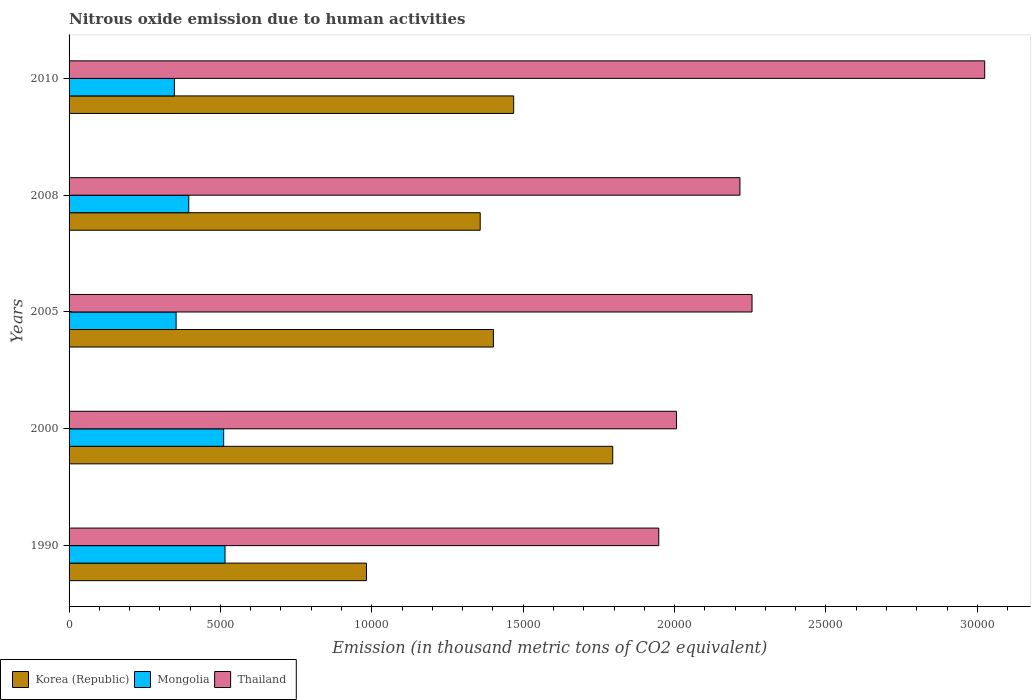How many different coloured bars are there?
Keep it short and to the point. 3. Are the number of bars per tick equal to the number of legend labels?
Offer a very short reply. Yes. How many bars are there on the 5th tick from the top?
Ensure brevity in your answer.  3. What is the label of the 3rd group of bars from the top?
Offer a very short reply. 2005. In how many cases, is the number of bars for a given year not equal to the number of legend labels?
Your answer should be compact. 0. What is the amount of nitrous oxide emitted in Thailand in 2000?
Your answer should be very brief. 2.01e+04. Across all years, what is the maximum amount of nitrous oxide emitted in Thailand?
Give a very brief answer. 3.02e+04. Across all years, what is the minimum amount of nitrous oxide emitted in Mongolia?
Your response must be concise. 3478.2. In which year was the amount of nitrous oxide emitted in Korea (Republic) maximum?
Give a very brief answer. 2000. What is the total amount of nitrous oxide emitted in Mongolia in the graph?
Keep it short and to the point. 2.12e+04. What is the difference between the amount of nitrous oxide emitted in Korea (Republic) in 2000 and that in 2010?
Offer a very short reply. 3272.5. What is the difference between the amount of nitrous oxide emitted in Korea (Republic) in 2010 and the amount of nitrous oxide emitted in Thailand in 2008?
Provide a short and direct response. -7473.8. What is the average amount of nitrous oxide emitted in Korea (Republic) per year?
Provide a succinct answer. 1.40e+04. In the year 2010, what is the difference between the amount of nitrous oxide emitted in Thailand and amount of nitrous oxide emitted in Mongolia?
Your answer should be compact. 2.68e+04. In how many years, is the amount of nitrous oxide emitted in Thailand greater than 16000 thousand metric tons?
Your response must be concise. 5. What is the ratio of the amount of nitrous oxide emitted in Mongolia in 1990 to that in 2000?
Make the answer very short. 1.01. What is the difference between the highest and the second highest amount of nitrous oxide emitted in Korea (Republic)?
Offer a very short reply. 3272.5. What is the difference between the highest and the lowest amount of nitrous oxide emitted in Thailand?
Your answer should be very brief. 1.08e+04. In how many years, is the amount of nitrous oxide emitted in Thailand greater than the average amount of nitrous oxide emitted in Thailand taken over all years?
Offer a very short reply. 1. What does the 2nd bar from the bottom in 2008 represents?
Provide a succinct answer. Mongolia. How many bars are there?
Offer a terse response. 15. Are all the bars in the graph horizontal?
Your response must be concise. Yes. How many years are there in the graph?
Make the answer very short. 5. What is the difference between two consecutive major ticks on the X-axis?
Your answer should be compact. 5000. Are the values on the major ticks of X-axis written in scientific E-notation?
Make the answer very short. No. Does the graph contain any zero values?
Offer a terse response. No. Does the graph contain grids?
Ensure brevity in your answer.  No. How many legend labels are there?
Offer a very short reply. 3. How are the legend labels stacked?
Keep it short and to the point. Horizontal. What is the title of the graph?
Your answer should be compact. Nitrous oxide emission due to human activities. Does "Uganda" appear as one of the legend labels in the graph?
Ensure brevity in your answer.  No. What is the label or title of the X-axis?
Make the answer very short. Emission (in thousand metric tons of CO2 equivalent). What is the Emission (in thousand metric tons of CO2 equivalent) of Korea (Republic) in 1990?
Ensure brevity in your answer.  9823.4. What is the Emission (in thousand metric tons of CO2 equivalent) of Mongolia in 1990?
Ensure brevity in your answer.  5151. What is the Emission (in thousand metric tons of CO2 equivalent) of Thailand in 1990?
Ensure brevity in your answer.  1.95e+04. What is the Emission (in thousand metric tons of CO2 equivalent) in Korea (Republic) in 2000?
Keep it short and to the point. 1.80e+04. What is the Emission (in thousand metric tons of CO2 equivalent) of Mongolia in 2000?
Your answer should be very brief. 5106.8. What is the Emission (in thousand metric tons of CO2 equivalent) of Thailand in 2000?
Keep it short and to the point. 2.01e+04. What is the Emission (in thousand metric tons of CO2 equivalent) of Korea (Republic) in 2005?
Offer a terse response. 1.40e+04. What is the Emission (in thousand metric tons of CO2 equivalent) of Mongolia in 2005?
Offer a terse response. 3535.4. What is the Emission (in thousand metric tons of CO2 equivalent) in Thailand in 2005?
Provide a short and direct response. 2.26e+04. What is the Emission (in thousand metric tons of CO2 equivalent) in Korea (Republic) in 2008?
Your answer should be compact. 1.36e+04. What is the Emission (in thousand metric tons of CO2 equivalent) of Mongolia in 2008?
Give a very brief answer. 3953.8. What is the Emission (in thousand metric tons of CO2 equivalent) in Thailand in 2008?
Ensure brevity in your answer.  2.22e+04. What is the Emission (in thousand metric tons of CO2 equivalent) of Korea (Republic) in 2010?
Keep it short and to the point. 1.47e+04. What is the Emission (in thousand metric tons of CO2 equivalent) of Mongolia in 2010?
Your answer should be compact. 3478.2. What is the Emission (in thousand metric tons of CO2 equivalent) of Thailand in 2010?
Offer a terse response. 3.02e+04. Across all years, what is the maximum Emission (in thousand metric tons of CO2 equivalent) in Korea (Republic)?
Your answer should be very brief. 1.80e+04. Across all years, what is the maximum Emission (in thousand metric tons of CO2 equivalent) in Mongolia?
Give a very brief answer. 5151. Across all years, what is the maximum Emission (in thousand metric tons of CO2 equivalent) in Thailand?
Your response must be concise. 3.02e+04. Across all years, what is the minimum Emission (in thousand metric tons of CO2 equivalent) in Korea (Republic)?
Your response must be concise. 9823.4. Across all years, what is the minimum Emission (in thousand metric tons of CO2 equivalent) of Mongolia?
Your answer should be very brief. 3478.2. Across all years, what is the minimum Emission (in thousand metric tons of CO2 equivalent) of Thailand?
Give a very brief answer. 1.95e+04. What is the total Emission (in thousand metric tons of CO2 equivalent) in Korea (Republic) in the graph?
Provide a short and direct response. 7.01e+04. What is the total Emission (in thousand metric tons of CO2 equivalent) of Mongolia in the graph?
Your answer should be very brief. 2.12e+04. What is the total Emission (in thousand metric tons of CO2 equivalent) of Thailand in the graph?
Give a very brief answer. 1.15e+05. What is the difference between the Emission (in thousand metric tons of CO2 equivalent) of Korea (Republic) in 1990 and that in 2000?
Ensure brevity in your answer.  -8134.7. What is the difference between the Emission (in thousand metric tons of CO2 equivalent) in Mongolia in 1990 and that in 2000?
Offer a very short reply. 44.2. What is the difference between the Emission (in thousand metric tons of CO2 equivalent) of Thailand in 1990 and that in 2000?
Ensure brevity in your answer.  -586.2. What is the difference between the Emission (in thousand metric tons of CO2 equivalent) of Korea (Republic) in 1990 and that in 2005?
Offer a terse response. -4193. What is the difference between the Emission (in thousand metric tons of CO2 equivalent) in Mongolia in 1990 and that in 2005?
Your answer should be very brief. 1615.6. What is the difference between the Emission (in thousand metric tons of CO2 equivalent) in Thailand in 1990 and that in 2005?
Your response must be concise. -3080.2. What is the difference between the Emission (in thousand metric tons of CO2 equivalent) in Korea (Republic) in 1990 and that in 2008?
Ensure brevity in your answer.  -3756.8. What is the difference between the Emission (in thousand metric tons of CO2 equivalent) of Mongolia in 1990 and that in 2008?
Keep it short and to the point. 1197.2. What is the difference between the Emission (in thousand metric tons of CO2 equivalent) of Thailand in 1990 and that in 2008?
Ensure brevity in your answer.  -2680.3. What is the difference between the Emission (in thousand metric tons of CO2 equivalent) of Korea (Republic) in 1990 and that in 2010?
Ensure brevity in your answer.  -4862.2. What is the difference between the Emission (in thousand metric tons of CO2 equivalent) of Mongolia in 1990 and that in 2010?
Make the answer very short. 1672.8. What is the difference between the Emission (in thousand metric tons of CO2 equivalent) of Thailand in 1990 and that in 2010?
Your answer should be compact. -1.08e+04. What is the difference between the Emission (in thousand metric tons of CO2 equivalent) of Korea (Republic) in 2000 and that in 2005?
Give a very brief answer. 3941.7. What is the difference between the Emission (in thousand metric tons of CO2 equivalent) in Mongolia in 2000 and that in 2005?
Keep it short and to the point. 1571.4. What is the difference between the Emission (in thousand metric tons of CO2 equivalent) of Thailand in 2000 and that in 2005?
Give a very brief answer. -2494. What is the difference between the Emission (in thousand metric tons of CO2 equivalent) of Korea (Republic) in 2000 and that in 2008?
Your answer should be very brief. 4377.9. What is the difference between the Emission (in thousand metric tons of CO2 equivalent) in Mongolia in 2000 and that in 2008?
Keep it short and to the point. 1153. What is the difference between the Emission (in thousand metric tons of CO2 equivalent) of Thailand in 2000 and that in 2008?
Your answer should be very brief. -2094.1. What is the difference between the Emission (in thousand metric tons of CO2 equivalent) of Korea (Republic) in 2000 and that in 2010?
Keep it short and to the point. 3272.5. What is the difference between the Emission (in thousand metric tons of CO2 equivalent) of Mongolia in 2000 and that in 2010?
Your response must be concise. 1628.6. What is the difference between the Emission (in thousand metric tons of CO2 equivalent) in Thailand in 2000 and that in 2010?
Ensure brevity in your answer.  -1.02e+04. What is the difference between the Emission (in thousand metric tons of CO2 equivalent) of Korea (Republic) in 2005 and that in 2008?
Provide a short and direct response. 436.2. What is the difference between the Emission (in thousand metric tons of CO2 equivalent) in Mongolia in 2005 and that in 2008?
Provide a succinct answer. -418.4. What is the difference between the Emission (in thousand metric tons of CO2 equivalent) in Thailand in 2005 and that in 2008?
Ensure brevity in your answer.  399.9. What is the difference between the Emission (in thousand metric tons of CO2 equivalent) of Korea (Republic) in 2005 and that in 2010?
Offer a terse response. -669.2. What is the difference between the Emission (in thousand metric tons of CO2 equivalent) in Mongolia in 2005 and that in 2010?
Offer a terse response. 57.2. What is the difference between the Emission (in thousand metric tons of CO2 equivalent) of Thailand in 2005 and that in 2010?
Offer a very short reply. -7685.5. What is the difference between the Emission (in thousand metric tons of CO2 equivalent) in Korea (Republic) in 2008 and that in 2010?
Keep it short and to the point. -1105.4. What is the difference between the Emission (in thousand metric tons of CO2 equivalent) of Mongolia in 2008 and that in 2010?
Ensure brevity in your answer.  475.6. What is the difference between the Emission (in thousand metric tons of CO2 equivalent) in Thailand in 2008 and that in 2010?
Keep it short and to the point. -8085.4. What is the difference between the Emission (in thousand metric tons of CO2 equivalent) in Korea (Republic) in 1990 and the Emission (in thousand metric tons of CO2 equivalent) in Mongolia in 2000?
Offer a very short reply. 4716.6. What is the difference between the Emission (in thousand metric tons of CO2 equivalent) of Korea (Republic) in 1990 and the Emission (in thousand metric tons of CO2 equivalent) of Thailand in 2000?
Provide a succinct answer. -1.02e+04. What is the difference between the Emission (in thousand metric tons of CO2 equivalent) in Mongolia in 1990 and the Emission (in thousand metric tons of CO2 equivalent) in Thailand in 2000?
Your answer should be very brief. -1.49e+04. What is the difference between the Emission (in thousand metric tons of CO2 equivalent) in Korea (Republic) in 1990 and the Emission (in thousand metric tons of CO2 equivalent) in Mongolia in 2005?
Offer a terse response. 6288. What is the difference between the Emission (in thousand metric tons of CO2 equivalent) of Korea (Republic) in 1990 and the Emission (in thousand metric tons of CO2 equivalent) of Thailand in 2005?
Your response must be concise. -1.27e+04. What is the difference between the Emission (in thousand metric tons of CO2 equivalent) of Mongolia in 1990 and the Emission (in thousand metric tons of CO2 equivalent) of Thailand in 2005?
Give a very brief answer. -1.74e+04. What is the difference between the Emission (in thousand metric tons of CO2 equivalent) of Korea (Republic) in 1990 and the Emission (in thousand metric tons of CO2 equivalent) of Mongolia in 2008?
Provide a succinct answer. 5869.6. What is the difference between the Emission (in thousand metric tons of CO2 equivalent) in Korea (Republic) in 1990 and the Emission (in thousand metric tons of CO2 equivalent) in Thailand in 2008?
Ensure brevity in your answer.  -1.23e+04. What is the difference between the Emission (in thousand metric tons of CO2 equivalent) of Mongolia in 1990 and the Emission (in thousand metric tons of CO2 equivalent) of Thailand in 2008?
Offer a very short reply. -1.70e+04. What is the difference between the Emission (in thousand metric tons of CO2 equivalent) in Korea (Republic) in 1990 and the Emission (in thousand metric tons of CO2 equivalent) in Mongolia in 2010?
Provide a succinct answer. 6345.2. What is the difference between the Emission (in thousand metric tons of CO2 equivalent) in Korea (Republic) in 1990 and the Emission (in thousand metric tons of CO2 equivalent) in Thailand in 2010?
Give a very brief answer. -2.04e+04. What is the difference between the Emission (in thousand metric tons of CO2 equivalent) in Mongolia in 1990 and the Emission (in thousand metric tons of CO2 equivalent) in Thailand in 2010?
Your response must be concise. -2.51e+04. What is the difference between the Emission (in thousand metric tons of CO2 equivalent) of Korea (Republic) in 2000 and the Emission (in thousand metric tons of CO2 equivalent) of Mongolia in 2005?
Offer a very short reply. 1.44e+04. What is the difference between the Emission (in thousand metric tons of CO2 equivalent) of Korea (Republic) in 2000 and the Emission (in thousand metric tons of CO2 equivalent) of Thailand in 2005?
Your answer should be compact. -4601.2. What is the difference between the Emission (in thousand metric tons of CO2 equivalent) of Mongolia in 2000 and the Emission (in thousand metric tons of CO2 equivalent) of Thailand in 2005?
Provide a short and direct response. -1.75e+04. What is the difference between the Emission (in thousand metric tons of CO2 equivalent) of Korea (Republic) in 2000 and the Emission (in thousand metric tons of CO2 equivalent) of Mongolia in 2008?
Offer a very short reply. 1.40e+04. What is the difference between the Emission (in thousand metric tons of CO2 equivalent) of Korea (Republic) in 2000 and the Emission (in thousand metric tons of CO2 equivalent) of Thailand in 2008?
Offer a terse response. -4201.3. What is the difference between the Emission (in thousand metric tons of CO2 equivalent) in Mongolia in 2000 and the Emission (in thousand metric tons of CO2 equivalent) in Thailand in 2008?
Your response must be concise. -1.71e+04. What is the difference between the Emission (in thousand metric tons of CO2 equivalent) of Korea (Republic) in 2000 and the Emission (in thousand metric tons of CO2 equivalent) of Mongolia in 2010?
Your answer should be very brief. 1.45e+04. What is the difference between the Emission (in thousand metric tons of CO2 equivalent) in Korea (Republic) in 2000 and the Emission (in thousand metric tons of CO2 equivalent) in Thailand in 2010?
Keep it short and to the point. -1.23e+04. What is the difference between the Emission (in thousand metric tons of CO2 equivalent) of Mongolia in 2000 and the Emission (in thousand metric tons of CO2 equivalent) of Thailand in 2010?
Ensure brevity in your answer.  -2.51e+04. What is the difference between the Emission (in thousand metric tons of CO2 equivalent) in Korea (Republic) in 2005 and the Emission (in thousand metric tons of CO2 equivalent) in Mongolia in 2008?
Make the answer very short. 1.01e+04. What is the difference between the Emission (in thousand metric tons of CO2 equivalent) in Korea (Republic) in 2005 and the Emission (in thousand metric tons of CO2 equivalent) in Thailand in 2008?
Provide a short and direct response. -8143. What is the difference between the Emission (in thousand metric tons of CO2 equivalent) in Mongolia in 2005 and the Emission (in thousand metric tons of CO2 equivalent) in Thailand in 2008?
Make the answer very short. -1.86e+04. What is the difference between the Emission (in thousand metric tons of CO2 equivalent) of Korea (Republic) in 2005 and the Emission (in thousand metric tons of CO2 equivalent) of Mongolia in 2010?
Make the answer very short. 1.05e+04. What is the difference between the Emission (in thousand metric tons of CO2 equivalent) in Korea (Republic) in 2005 and the Emission (in thousand metric tons of CO2 equivalent) in Thailand in 2010?
Offer a terse response. -1.62e+04. What is the difference between the Emission (in thousand metric tons of CO2 equivalent) in Mongolia in 2005 and the Emission (in thousand metric tons of CO2 equivalent) in Thailand in 2010?
Offer a very short reply. -2.67e+04. What is the difference between the Emission (in thousand metric tons of CO2 equivalent) in Korea (Republic) in 2008 and the Emission (in thousand metric tons of CO2 equivalent) in Mongolia in 2010?
Give a very brief answer. 1.01e+04. What is the difference between the Emission (in thousand metric tons of CO2 equivalent) in Korea (Republic) in 2008 and the Emission (in thousand metric tons of CO2 equivalent) in Thailand in 2010?
Provide a short and direct response. -1.67e+04. What is the difference between the Emission (in thousand metric tons of CO2 equivalent) in Mongolia in 2008 and the Emission (in thousand metric tons of CO2 equivalent) in Thailand in 2010?
Make the answer very short. -2.63e+04. What is the average Emission (in thousand metric tons of CO2 equivalent) of Korea (Republic) per year?
Keep it short and to the point. 1.40e+04. What is the average Emission (in thousand metric tons of CO2 equivalent) in Mongolia per year?
Keep it short and to the point. 4245.04. What is the average Emission (in thousand metric tons of CO2 equivalent) of Thailand per year?
Your response must be concise. 2.29e+04. In the year 1990, what is the difference between the Emission (in thousand metric tons of CO2 equivalent) of Korea (Republic) and Emission (in thousand metric tons of CO2 equivalent) of Mongolia?
Your answer should be compact. 4672.4. In the year 1990, what is the difference between the Emission (in thousand metric tons of CO2 equivalent) of Korea (Republic) and Emission (in thousand metric tons of CO2 equivalent) of Thailand?
Your response must be concise. -9655.7. In the year 1990, what is the difference between the Emission (in thousand metric tons of CO2 equivalent) of Mongolia and Emission (in thousand metric tons of CO2 equivalent) of Thailand?
Offer a terse response. -1.43e+04. In the year 2000, what is the difference between the Emission (in thousand metric tons of CO2 equivalent) of Korea (Republic) and Emission (in thousand metric tons of CO2 equivalent) of Mongolia?
Offer a terse response. 1.29e+04. In the year 2000, what is the difference between the Emission (in thousand metric tons of CO2 equivalent) in Korea (Republic) and Emission (in thousand metric tons of CO2 equivalent) in Thailand?
Make the answer very short. -2107.2. In the year 2000, what is the difference between the Emission (in thousand metric tons of CO2 equivalent) of Mongolia and Emission (in thousand metric tons of CO2 equivalent) of Thailand?
Keep it short and to the point. -1.50e+04. In the year 2005, what is the difference between the Emission (in thousand metric tons of CO2 equivalent) in Korea (Republic) and Emission (in thousand metric tons of CO2 equivalent) in Mongolia?
Offer a terse response. 1.05e+04. In the year 2005, what is the difference between the Emission (in thousand metric tons of CO2 equivalent) of Korea (Republic) and Emission (in thousand metric tons of CO2 equivalent) of Thailand?
Make the answer very short. -8542.9. In the year 2005, what is the difference between the Emission (in thousand metric tons of CO2 equivalent) in Mongolia and Emission (in thousand metric tons of CO2 equivalent) in Thailand?
Offer a terse response. -1.90e+04. In the year 2008, what is the difference between the Emission (in thousand metric tons of CO2 equivalent) in Korea (Republic) and Emission (in thousand metric tons of CO2 equivalent) in Mongolia?
Your answer should be compact. 9626.4. In the year 2008, what is the difference between the Emission (in thousand metric tons of CO2 equivalent) of Korea (Republic) and Emission (in thousand metric tons of CO2 equivalent) of Thailand?
Make the answer very short. -8579.2. In the year 2008, what is the difference between the Emission (in thousand metric tons of CO2 equivalent) of Mongolia and Emission (in thousand metric tons of CO2 equivalent) of Thailand?
Your answer should be compact. -1.82e+04. In the year 2010, what is the difference between the Emission (in thousand metric tons of CO2 equivalent) in Korea (Republic) and Emission (in thousand metric tons of CO2 equivalent) in Mongolia?
Make the answer very short. 1.12e+04. In the year 2010, what is the difference between the Emission (in thousand metric tons of CO2 equivalent) of Korea (Republic) and Emission (in thousand metric tons of CO2 equivalent) of Thailand?
Provide a short and direct response. -1.56e+04. In the year 2010, what is the difference between the Emission (in thousand metric tons of CO2 equivalent) of Mongolia and Emission (in thousand metric tons of CO2 equivalent) of Thailand?
Provide a short and direct response. -2.68e+04. What is the ratio of the Emission (in thousand metric tons of CO2 equivalent) of Korea (Republic) in 1990 to that in 2000?
Offer a terse response. 0.55. What is the ratio of the Emission (in thousand metric tons of CO2 equivalent) of Mongolia in 1990 to that in 2000?
Offer a very short reply. 1.01. What is the ratio of the Emission (in thousand metric tons of CO2 equivalent) in Thailand in 1990 to that in 2000?
Keep it short and to the point. 0.97. What is the ratio of the Emission (in thousand metric tons of CO2 equivalent) of Korea (Republic) in 1990 to that in 2005?
Offer a very short reply. 0.7. What is the ratio of the Emission (in thousand metric tons of CO2 equivalent) in Mongolia in 1990 to that in 2005?
Your answer should be very brief. 1.46. What is the ratio of the Emission (in thousand metric tons of CO2 equivalent) of Thailand in 1990 to that in 2005?
Your answer should be very brief. 0.86. What is the ratio of the Emission (in thousand metric tons of CO2 equivalent) in Korea (Republic) in 1990 to that in 2008?
Make the answer very short. 0.72. What is the ratio of the Emission (in thousand metric tons of CO2 equivalent) of Mongolia in 1990 to that in 2008?
Your answer should be compact. 1.3. What is the ratio of the Emission (in thousand metric tons of CO2 equivalent) of Thailand in 1990 to that in 2008?
Your answer should be compact. 0.88. What is the ratio of the Emission (in thousand metric tons of CO2 equivalent) of Korea (Republic) in 1990 to that in 2010?
Give a very brief answer. 0.67. What is the ratio of the Emission (in thousand metric tons of CO2 equivalent) in Mongolia in 1990 to that in 2010?
Keep it short and to the point. 1.48. What is the ratio of the Emission (in thousand metric tons of CO2 equivalent) of Thailand in 1990 to that in 2010?
Offer a very short reply. 0.64. What is the ratio of the Emission (in thousand metric tons of CO2 equivalent) in Korea (Republic) in 2000 to that in 2005?
Provide a short and direct response. 1.28. What is the ratio of the Emission (in thousand metric tons of CO2 equivalent) in Mongolia in 2000 to that in 2005?
Your response must be concise. 1.44. What is the ratio of the Emission (in thousand metric tons of CO2 equivalent) of Thailand in 2000 to that in 2005?
Your answer should be compact. 0.89. What is the ratio of the Emission (in thousand metric tons of CO2 equivalent) in Korea (Republic) in 2000 to that in 2008?
Make the answer very short. 1.32. What is the ratio of the Emission (in thousand metric tons of CO2 equivalent) of Mongolia in 2000 to that in 2008?
Keep it short and to the point. 1.29. What is the ratio of the Emission (in thousand metric tons of CO2 equivalent) in Thailand in 2000 to that in 2008?
Provide a succinct answer. 0.91. What is the ratio of the Emission (in thousand metric tons of CO2 equivalent) in Korea (Republic) in 2000 to that in 2010?
Keep it short and to the point. 1.22. What is the ratio of the Emission (in thousand metric tons of CO2 equivalent) in Mongolia in 2000 to that in 2010?
Provide a short and direct response. 1.47. What is the ratio of the Emission (in thousand metric tons of CO2 equivalent) in Thailand in 2000 to that in 2010?
Your answer should be very brief. 0.66. What is the ratio of the Emission (in thousand metric tons of CO2 equivalent) of Korea (Republic) in 2005 to that in 2008?
Offer a very short reply. 1.03. What is the ratio of the Emission (in thousand metric tons of CO2 equivalent) in Mongolia in 2005 to that in 2008?
Give a very brief answer. 0.89. What is the ratio of the Emission (in thousand metric tons of CO2 equivalent) in Korea (Republic) in 2005 to that in 2010?
Provide a succinct answer. 0.95. What is the ratio of the Emission (in thousand metric tons of CO2 equivalent) in Mongolia in 2005 to that in 2010?
Provide a short and direct response. 1.02. What is the ratio of the Emission (in thousand metric tons of CO2 equivalent) of Thailand in 2005 to that in 2010?
Your answer should be compact. 0.75. What is the ratio of the Emission (in thousand metric tons of CO2 equivalent) of Korea (Republic) in 2008 to that in 2010?
Make the answer very short. 0.92. What is the ratio of the Emission (in thousand metric tons of CO2 equivalent) of Mongolia in 2008 to that in 2010?
Make the answer very short. 1.14. What is the ratio of the Emission (in thousand metric tons of CO2 equivalent) in Thailand in 2008 to that in 2010?
Your response must be concise. 0.73. What is the difference between the highest and the second highest Emission (in thousand metric tons of CO2 equivalent) in Korea (Republic)?
Provide a succinct answer. 3272.5. What is the difference between the highest and the second highest Emission (in thousand metric tons of CO2 equivalent) of Mongolia?
Offer a very short reply. 44.2. What is the difference between the highest and the second highest Emission (in thousand metric tons of CO2 equivalent) of Thailand?
Make the answer very short. 7685.5. What is the difference between the highest and the lowest Emission (in thousand metric tons of CO2 equivalent) in Korea (Republic)?
Make the answer very short. 8134.7. What is the difference between the highest and the lowest Emission (in thousand metric tons of CO2 equivalent) in Mongolia?
Your answer should be compact. 1672.8. What is the difference between the highest and the lowest Emission (in thousand metric tons of CO2 equivalent) in Thailand?
Give a very brief answer. 1.08e+04. 